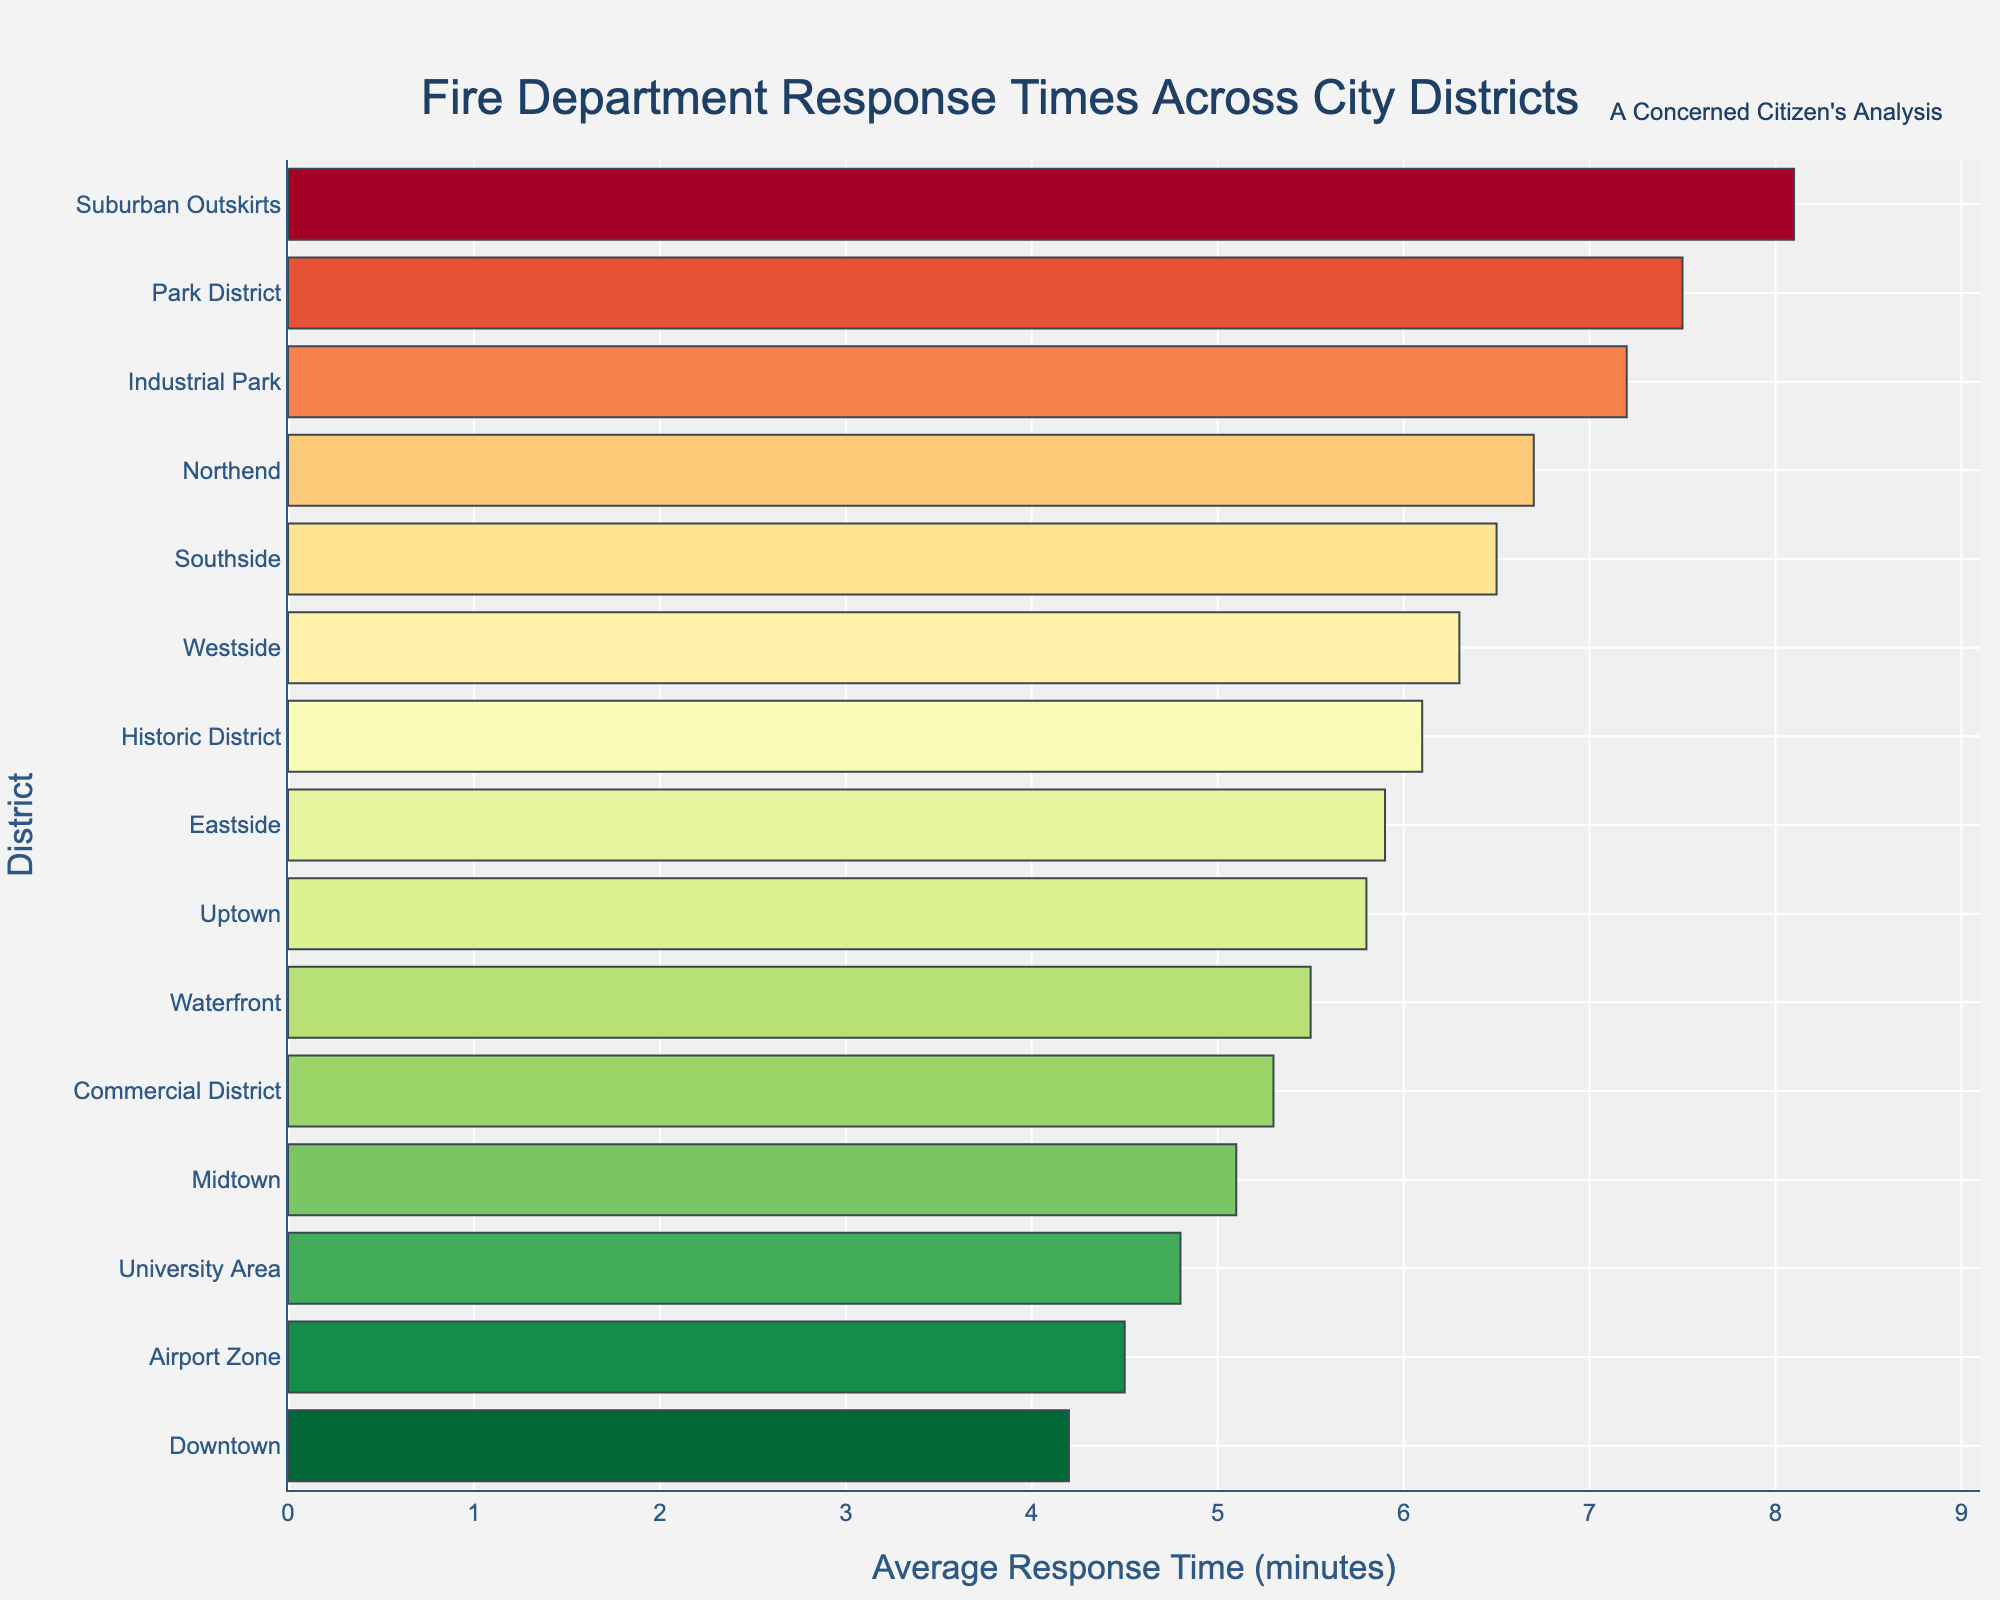What's the district with the fastest response time? The district with the shortest average response time is Downtown, at 4.2 minutes, as it is the first bar shown in the sorted bar chart.
Answer: Downtown What's the average response time for districts with response times over 7 minutes? The only districts with response times over 7 minutes are Industrial Park (7.2), Park District (7.5), and Suburban Outskirts (8.1). Adding these gives 7.2 + 7.5 + 8.1 = 22.8. Then, divide by 3 to find the average: 22.8 / 3 = 7.6 minutes.
Answer: 7.6 minutes How much faster is the response time in the University Area compared to Northend? The response time for the University Area is 4.8 minutes, and for Northend, it is 6.7 minutes. The difference is 6.7 - 4.8 = 1.9 minutes.
Answer: 1.9 minutes Which district has the longest response time, and what is it? The longest response time is in the Suburban Outskirts, at 8.1 minutes, as it is the last bar shown in the sorted bar chart.
Answer: Suburban Outskirts How many districts have a response time less than 6 minutes? The districts are Downtown (4.2), University Area (4.8), Airport Zone (4.5), Waterfront (5.5), and Midtown (5.1), totaling 5 districts.
Answer: 5 districts What is the difference between the average response times of the Westside and the Commercial District? The response time for Westside is 6.3 minutes, and for the Commercial District, it is 5.3 minutes. The difference is 6.3 - 5.3 = 1 minute.
Answer: 1 minute What is the sum of the average response times for Downtown, Airport Zone, and University Area? The response times are 4.2, 4.5, and 4.8 minutes respectively. Summing these gives 4.2 + 4.5 + 4.8 = 13.5 minutes.
Answer: 13.5 minutes Is the response time for Southside faster or slower than that for the Historic District? The response time for Southside is 6.5 minutes, and for the Historic District, it is 6.1 minutes. Since 6.5 is more than 6.1, Southside is slower.
Answer: Slower Which district has a visually noticeable red bar indicating the slowest response time among those below 5 minutes? The Airport Zone, with a response time of 4.5 minutes, shows a red bar among the districts with response times below 5 minutes.
Answer: Airport Zone Among the districts with response times between 5 and 6 minutes, which has the longest response time? The district with the longest response time in this range is Eastside, with a response time of 5.9 minutes.
Answer: Eastside 